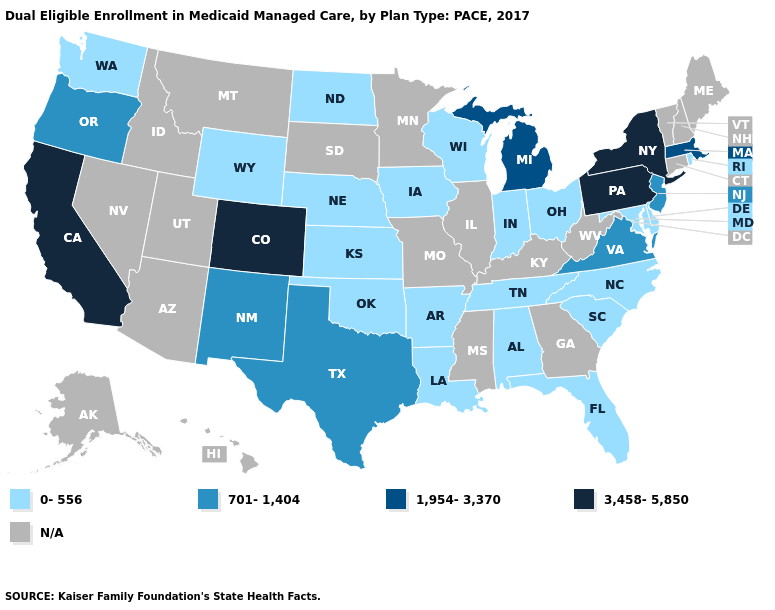What is the value of Vermont?
Quick response, please. N/A. Name the states that have a value in the range N/A?
Answer briefly. Alaska, Arizona, Connecticut, Georgia, Hawaii, Idaho, Illinois, Kentucky, Maine, Minnesota, Mississippi, Missouri, Montana, Nevada, New Hampshire, South Dakota, Utah, Vermont, West Virginia. Name the states that have a value in the range N/A?
Concise answer only. Alaska, Arizona, Connecticut, Georgia, Hawaii, Idaho, Illinois, Kentucky, Maine, Minnesota, Mississippi, Missouri, Montana, Nevada, New Hampshire, South Dakota, Utah, Vermont, West Virginia. Among the states that border Nevada , does Oregon have the highest value?
Concise answer only. No. What is the value of South Carolina?
Concise answer only. 0-556. Does the map have missing data?
Write a very short answer. Yes. Name the states that have a value in the range 701-1,404?
Keep it brief. New Jersey, New Mexico, Oregon, Texas, Virginia. Which states have the highest value in the USA?
Short answer required. California, Colorado, New York, Pennsylvania. What is the highest value in the MidWest ?
Answer briefly. 1,954-3,370. Among the states that border Louisiana , which have the lowest value?
Write a very short answer. Arkansas. What is the value of Minnesota?
Write a very short answer. N/A. 